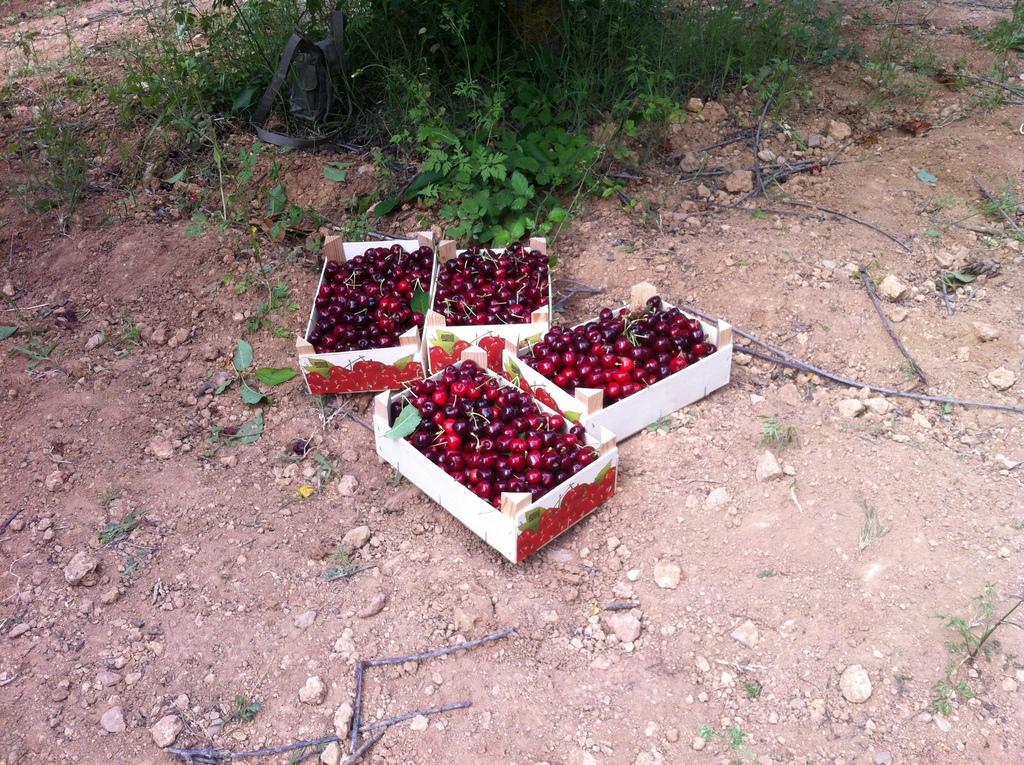Please provide a concise description of this image. This image is taken outdoors. At the bottom of the image there is a ground with grass and many pebbles and stones on it. At the top of the image there are a few plants with leaves and stems. In the middle of the image there are four baskets of cherries on the ground. 